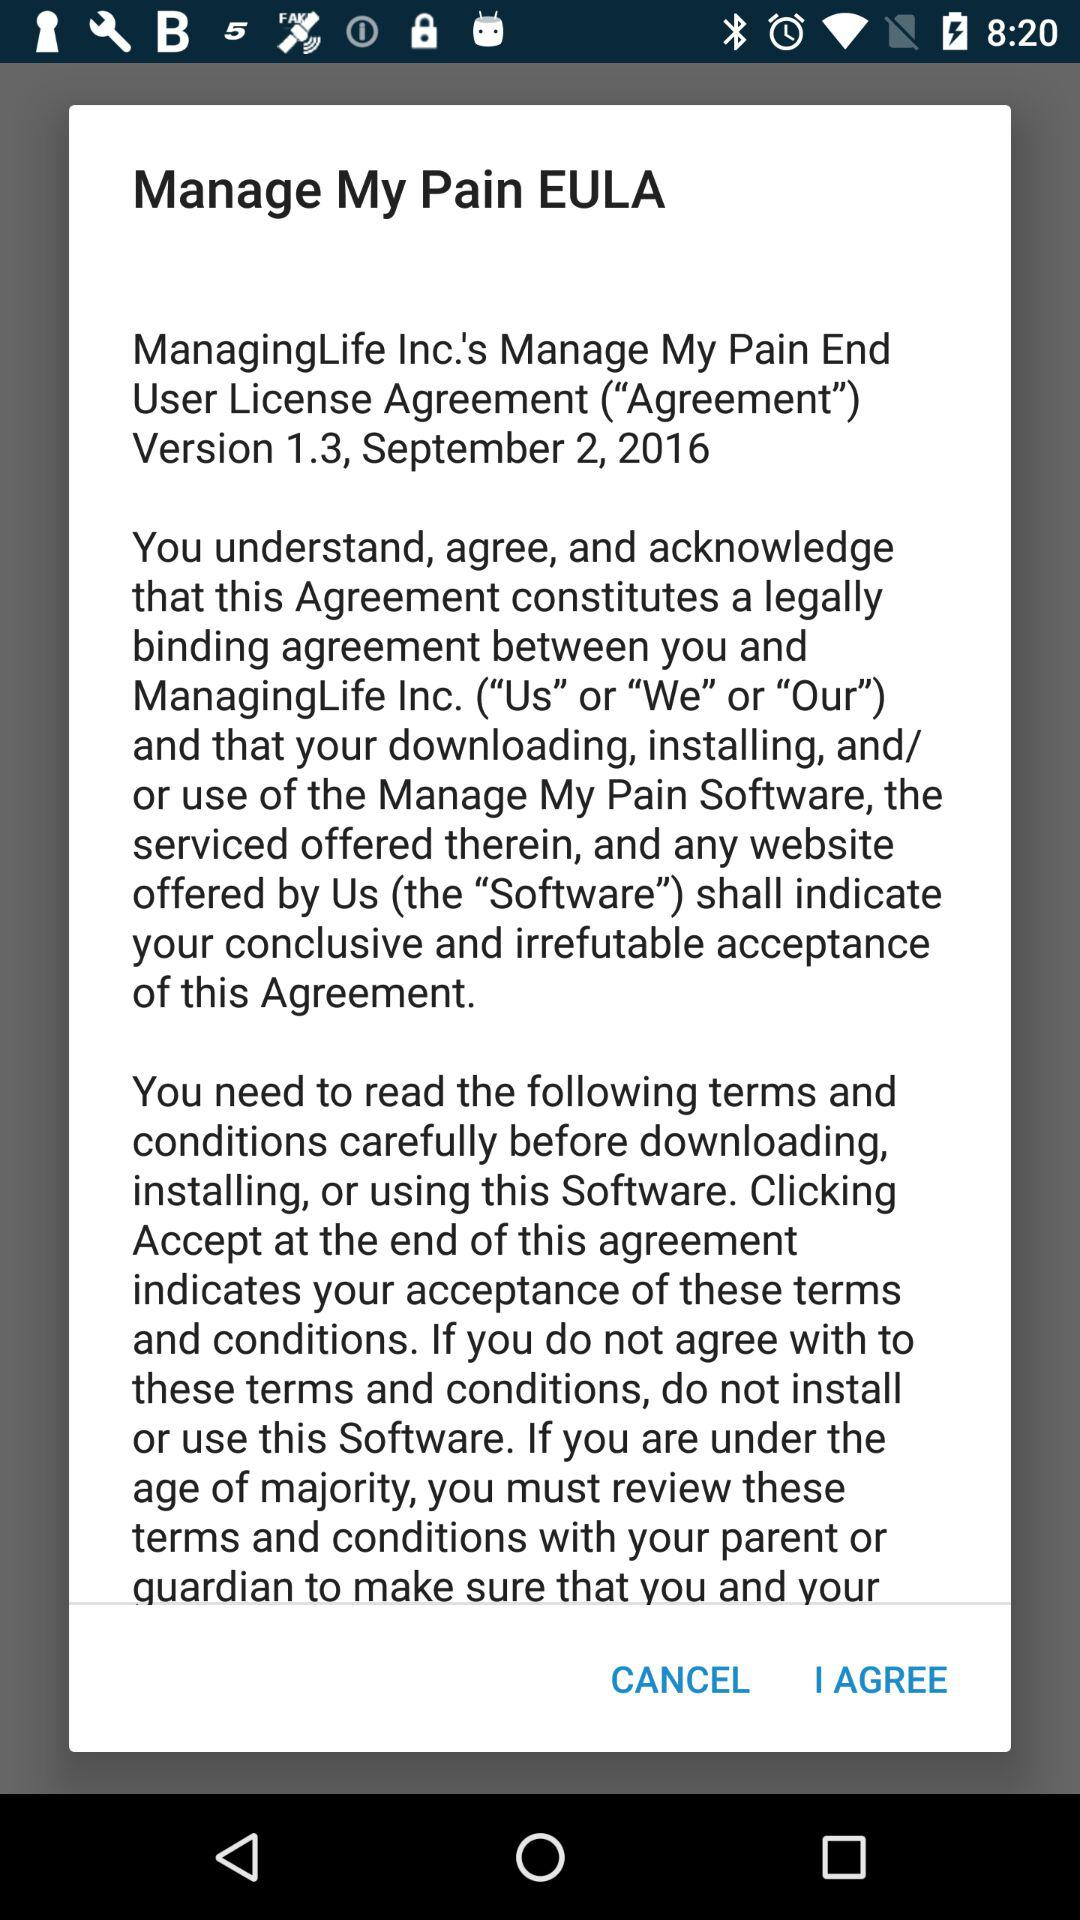What is the date of the version? The date is September 2, 2016. 